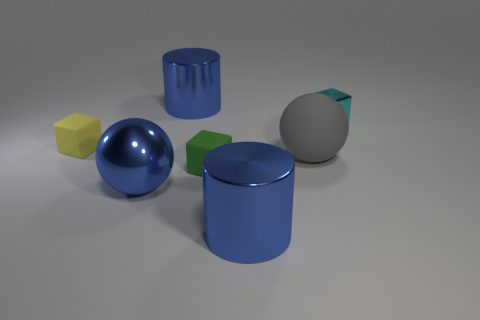There is a big thing that is behind the big gray sphere; is its color the same as the big metallic sphere?
Your response must be concise. Yes. Are there fewer green objects in front of the green cube than tiny yellow rubber objects?
Provide a short and direct response. Yes. There is a green object that is made of the same material as the small yellow object; what is its shape?
Make the answer very short. Cube. Is the small green thing made of the same material as the cyan block?
Keep it short and to the point. No. Are there fewer large blue spheres on the left side of the yellow cube than small objects that are to the left of the tiny green cube?
Offer a terse response. Yes. What number of small cubes are to the left of the large ball that is left of the green rubber block that is in front of the gray matte thing?
Your response must be concise. 1. Does the matte ball have the same color as the shiny cube?
Make the answer very short. No. Are there any objects of the same color as the metallic ball?
Provide a short and direct response. Yes. There is a rubber block that is the same size as the green matte thing; what is its color?
Provide a short and direct response. Yellow. Are there any metallic things of the same shape as the large gray rubber thing?
Your answer should be very brief. Yes. 